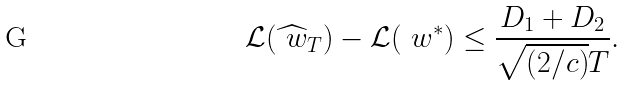Convert formula to latex. <formula><loc_0><loc_0><loc_500><loc_500>\mathcal { L } ( \widehat { \ w } _ { T } ) - \mathcal { L } ( \ w ^ { * } ) \leq \frac { D _ { 1 } + D _ { 2 } } { \sqrt { ( 2 / c ) } T } .</formula> 